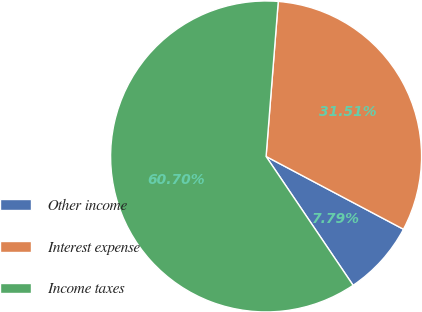Convert chart to OTSL. <chart><loc_0><loc_0><loc_500><loc_500><pie_chart><fcel>Other income<fcel>Interest expense<fcel>Income taxes<nl><fcel>7.79%<fcel>31.51%<fcel>60.7%<nl></chart> 